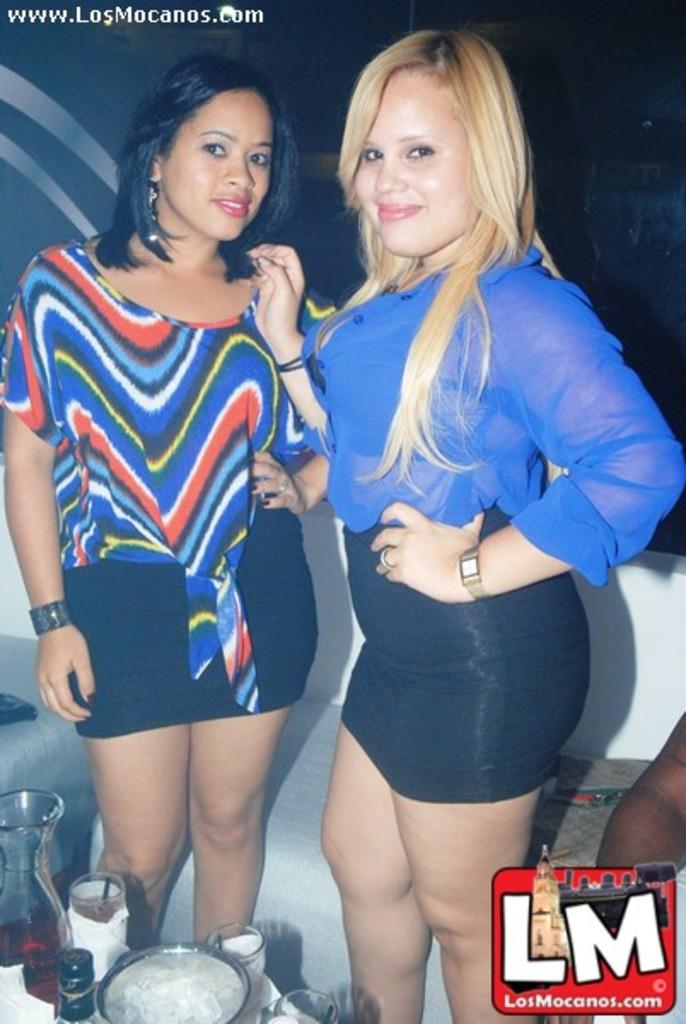<image>
Describe the image concisely. a sign that had the word LM on it next to girls 